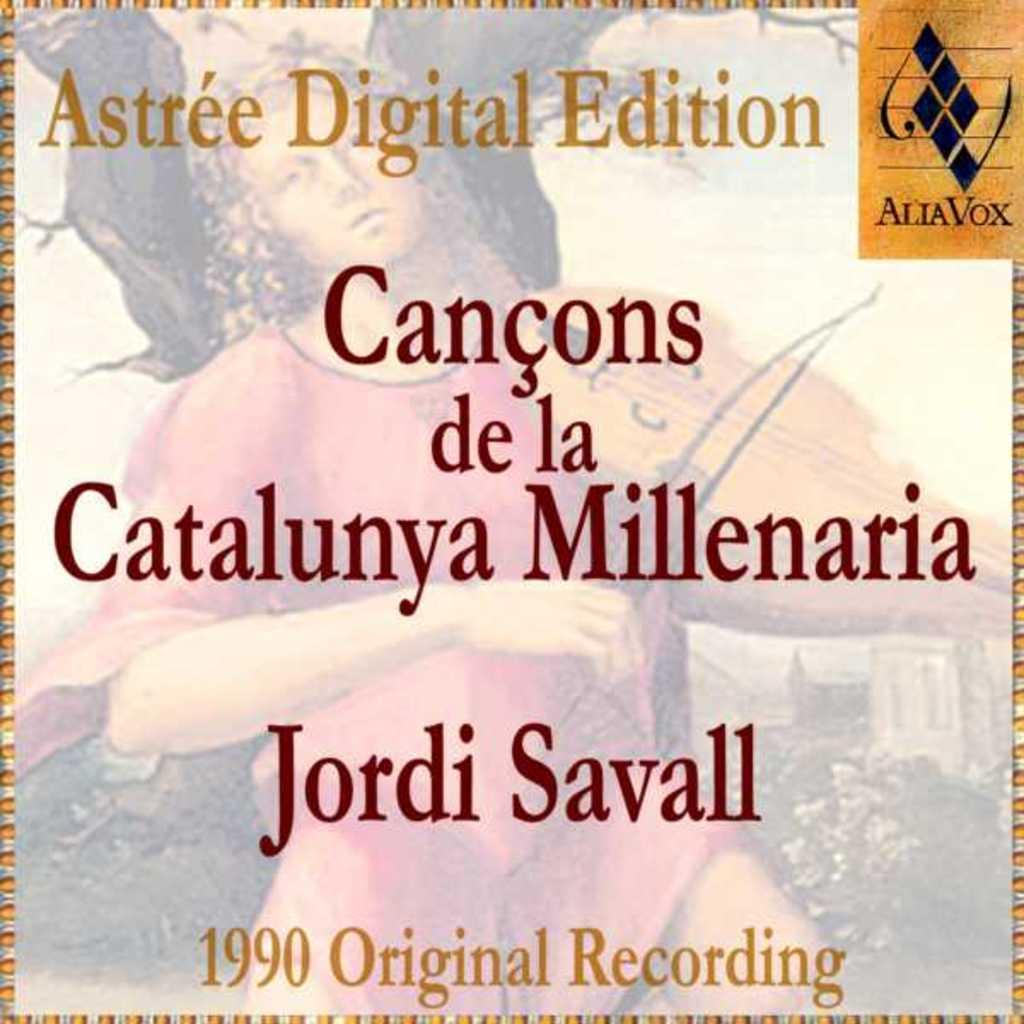<image>
Describe the image concisely. Astree digital edition of canons de la catalunya Millenaria 